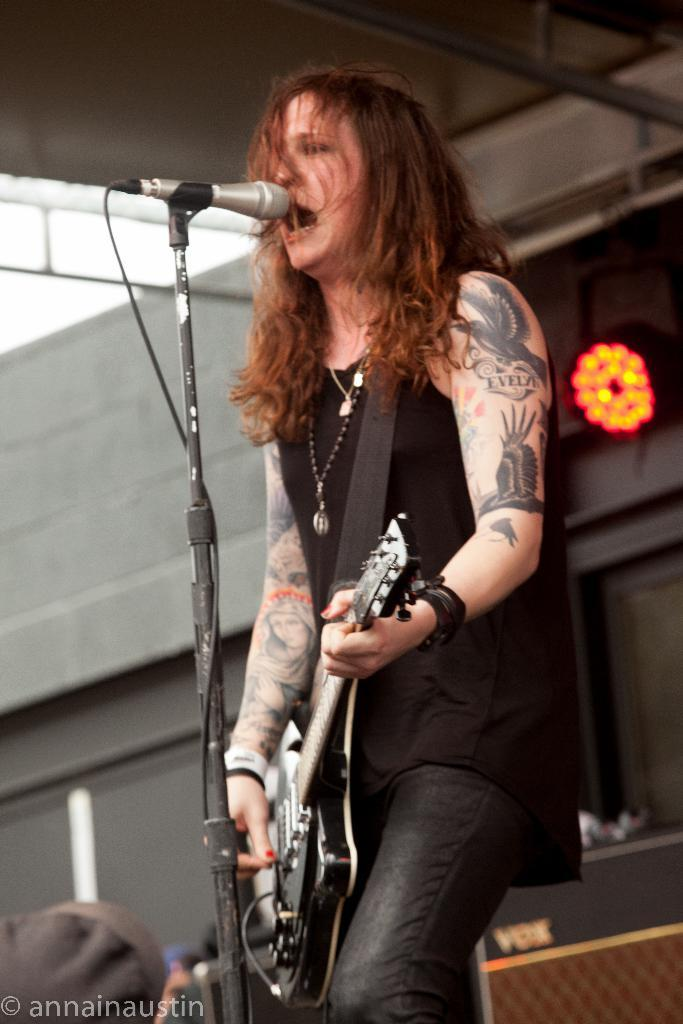What is the main subject of the image? The main subject of the image is a woman. What is the woman doing in the image? The woman is standing at the center of the image, holding a guitar in her hand, and singing on a microphone. What can be seen in the background of the image? There is a lighting arrangement in the background of the image. How many dogs are playing with the monkey in the image? There are no dogs or monkeys present in the image. The image features a woman holding a guitar and singing on a microphone, with a lighting arrangement in the background. 